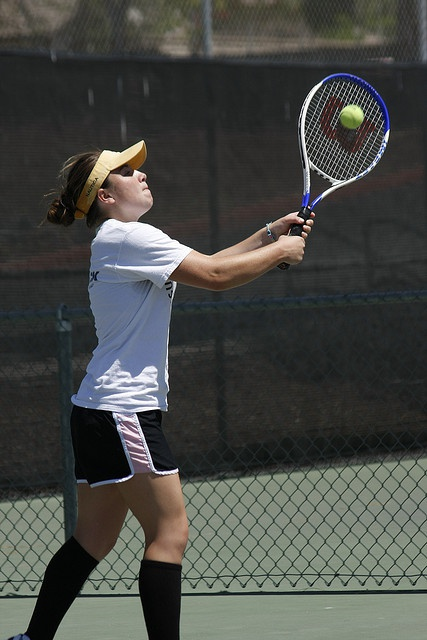Describe the objects in this image and their specific colors. I can see people in gray, black, and lightgray tones, tennis racket in gray, black, darkgray, and lightgray tones, and sports ball in gray, darkgreen, khaki, and olive tones in this image. 